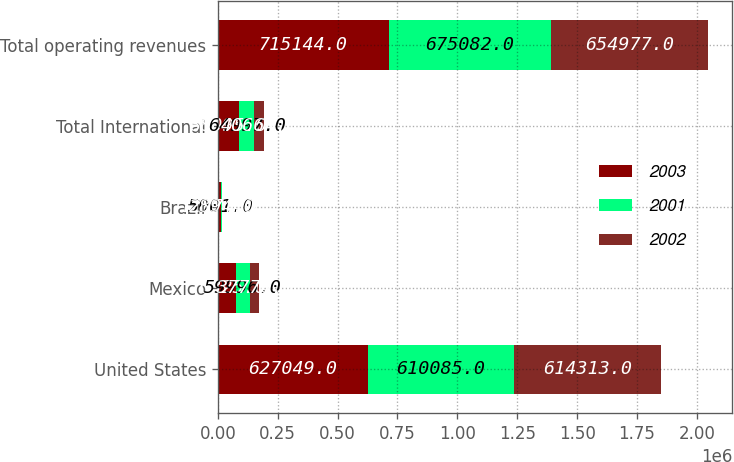<chart> <loc_0><loc_0><loc_500><loc_500><stacked_bar_chart><ecel><fcel>United States<fcel>Mexico<fcel>Brazil<fcel>Total International<fcel>Total operating revenues<nl><fcel>2003<fcel>627049<fcel>76325<fcel>11770<fcel>88095<fcel>715144<nl><fcel>2001<fcel>610085<fcel>59996<fcel>5001<fcel>64997<fcel>675082<nl><fcel>2002<fcel>614313<fcel>37770<fcel>2894<fcel>40664<fcel>654977<nl></chart> 